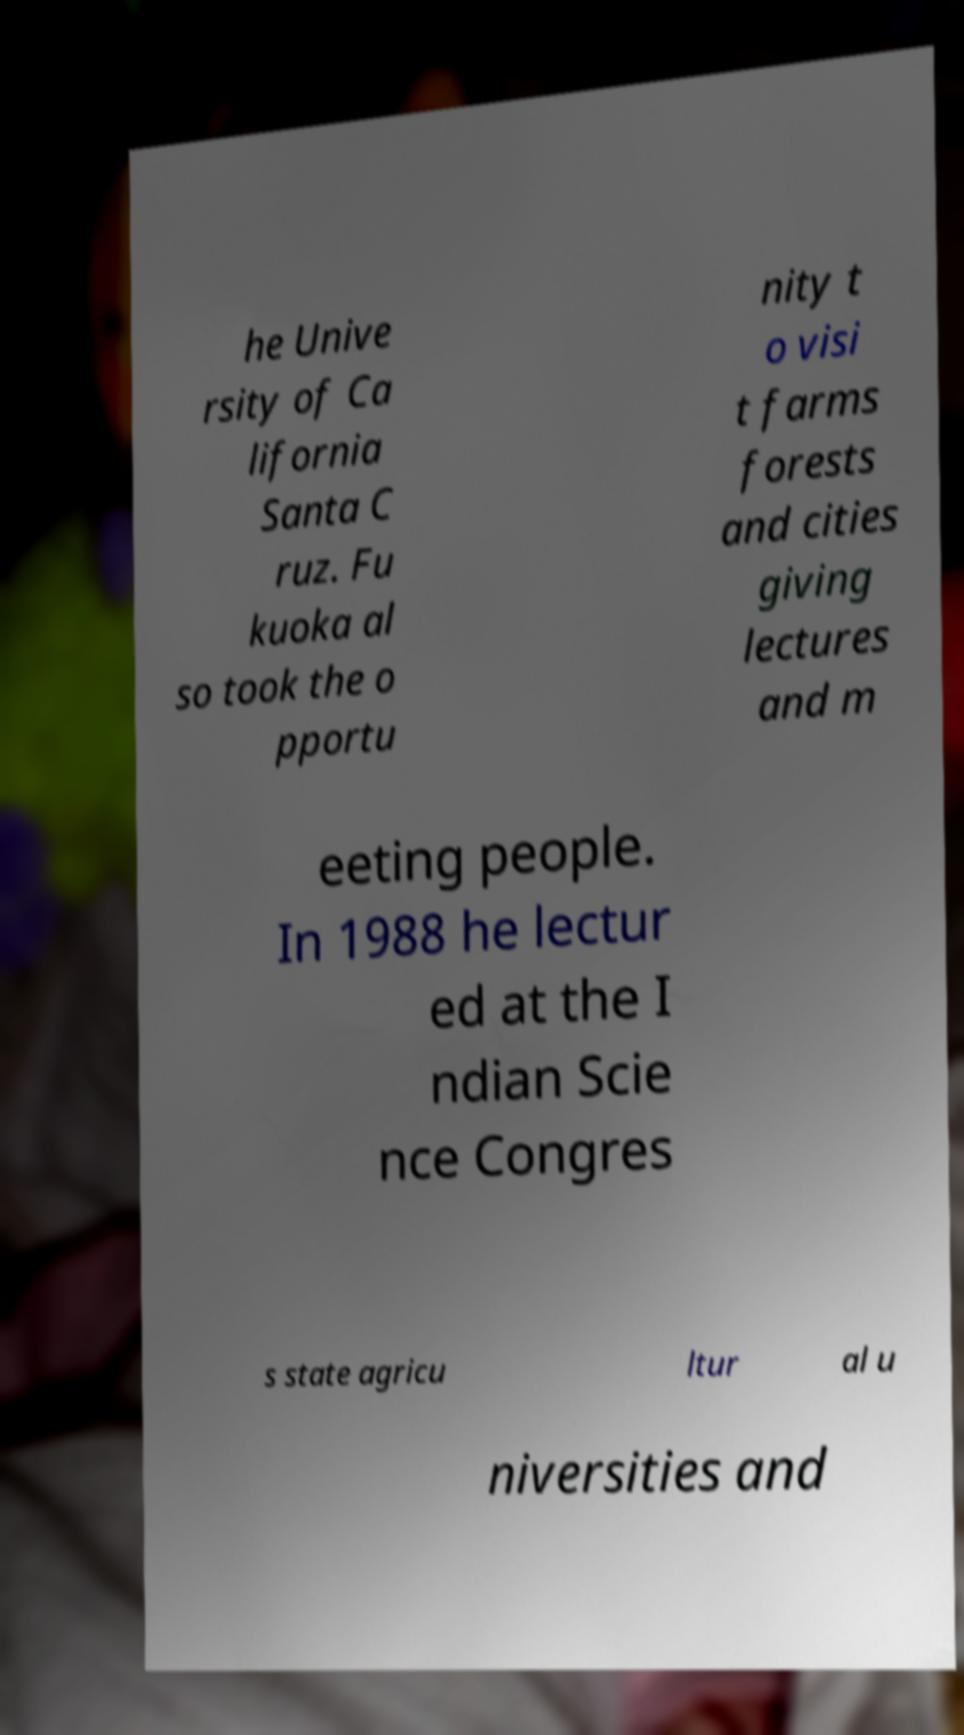Could you assist in decoding the text presented in this image and type it out clearly? he Unive rsity of Ca lifornia Santa C ruz. Fu kuoka al so took the o pportu nity t o visi t farms forests and cities giving lectures and m eeting people. In 1988 he lectur ed at the I ndian Scie nce Congres s state agricu ltur al u niversities and 